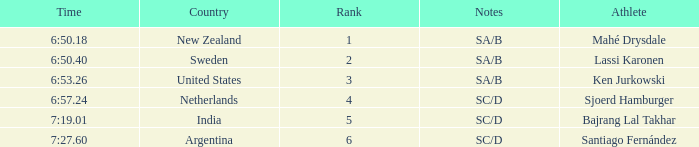What is listed in notes for the athlete, lassi karonen? SA/B. 